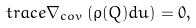<formula> <loc_0><loc_0><loc_500><loc_500>t r a c e \nabla _ { c o v } \left ( \rho ( Q ) d u \right ) = 0 ,</formula> 